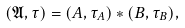Convert formula to latex. <formula><loc_0><loc_0><loc_500><loc_500>( \mathfrak { A } , \tau ) = ( A , \tau _ { A } ) * ( B , \tau _ { B } ) ,</formula> 